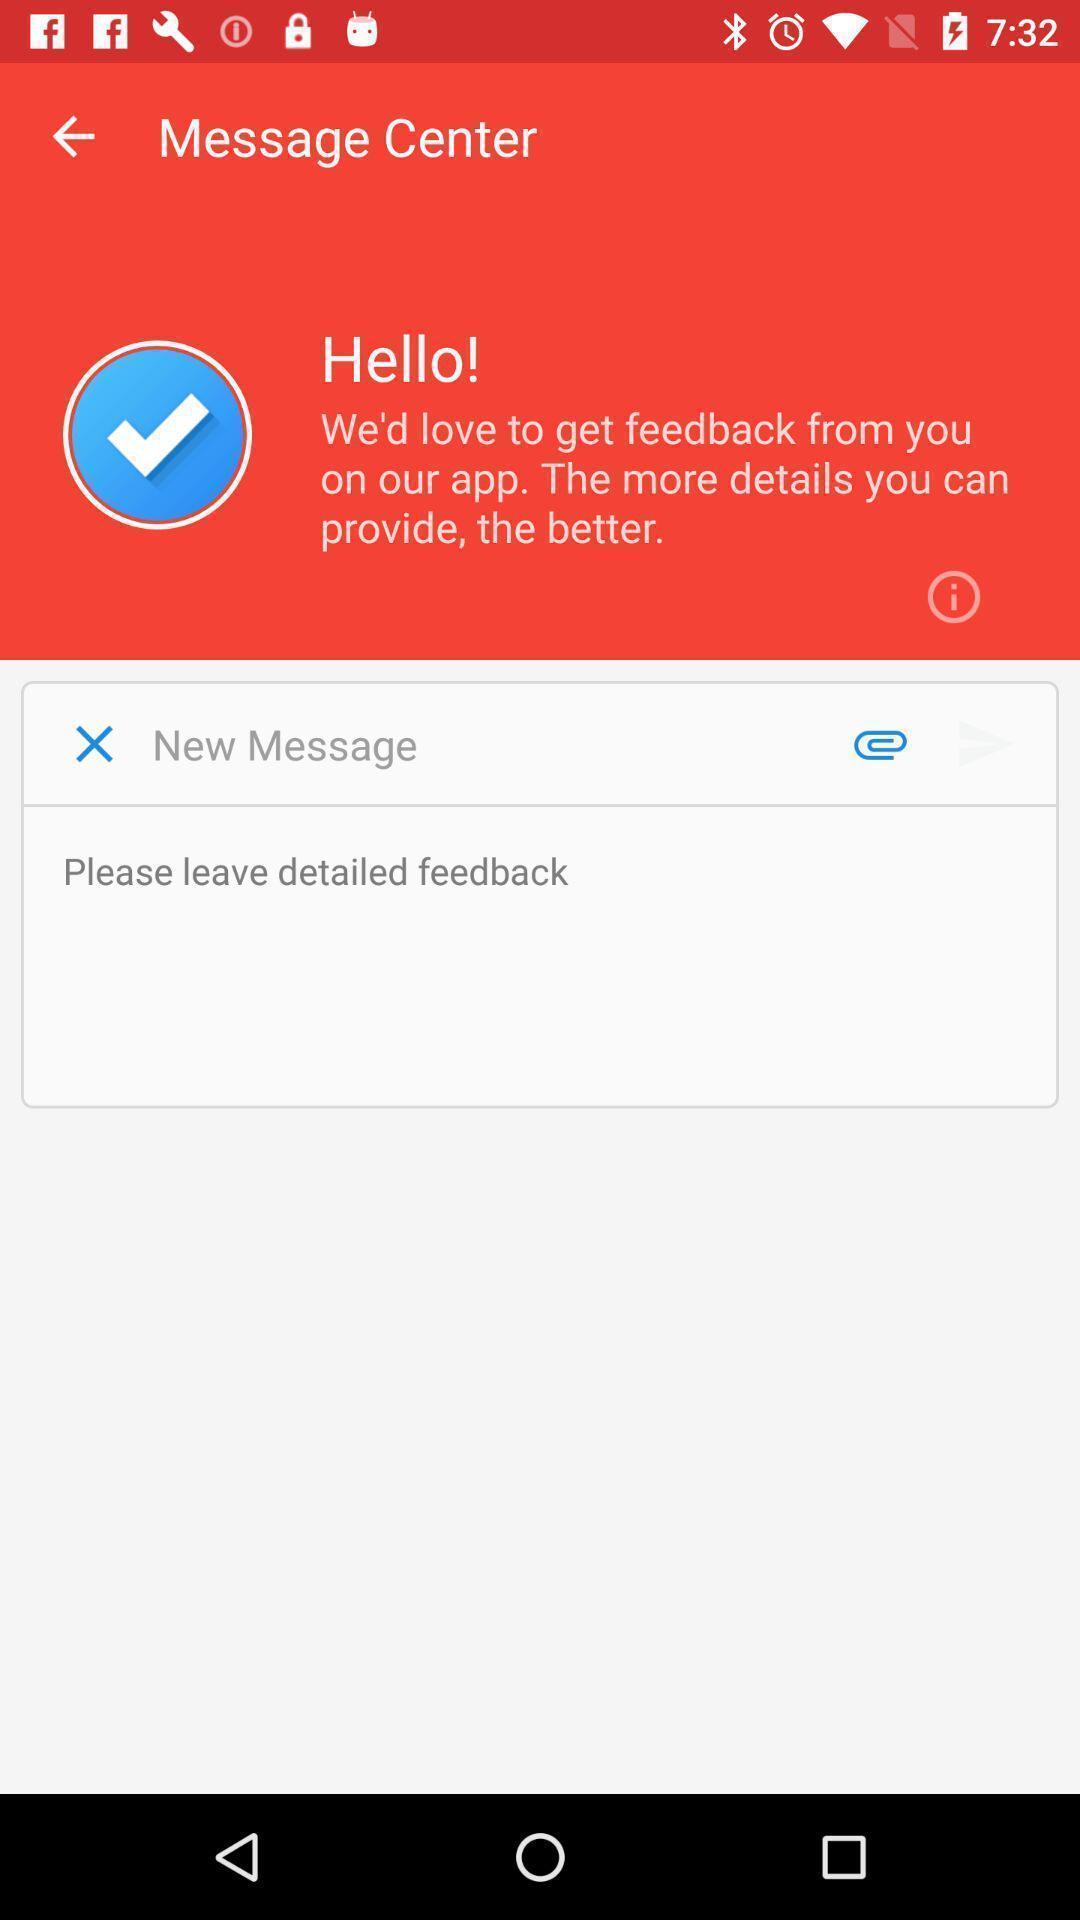Describe the visual elements of this screenshot. Page showing message center. 